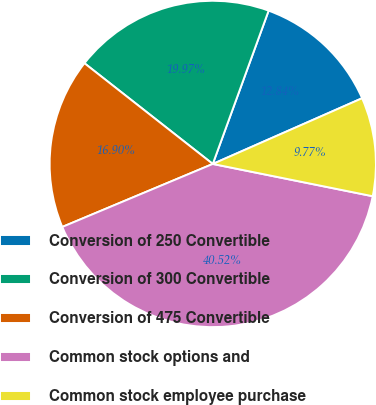Convert chart to OTSL. <chart><loc_0><loc_0><loc_500><loc_500><pie_chart><fcel>Conversion of 250 Convertible<fcel>Conversion of 300 Convertible<fcel>Conversion of 475 Convertible<fcel>Common stock options and<fcel>Common stock employee purchase<nl><fcel>12.84%<fcel>19.97%<fcel>16.9%<fcel>40.52%<fcel>9.77%<nl></chart> 